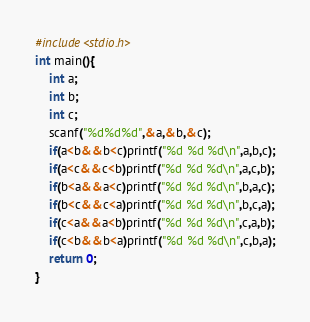Convert code to text. <code><loc_0><loc_0><loc_500><loc_500><_C_>#include<stdio.h>
int main(){
    int a;
    int b;
    int c;
    scanf("%d%d%d",&a,&b,&c);
    if(a<b&&b<c)printf("%d %d %d\n",a,b,c);
    if(a<c&&c<b)printf("%d %d %d\n",a,c,b);
    if(b<a&&a<c)printf("%d %d %d\n",b,a,c);
    if(b<c&&c<a)printf("%d %d %d\n",b,c,a);
    if(c<a&&a<b)printf("%d %d %d\n",c,a,b);
    if(c<b&&b<a)printf("%d %d %d\n",c,b,a);
    return 0;
}</code> 